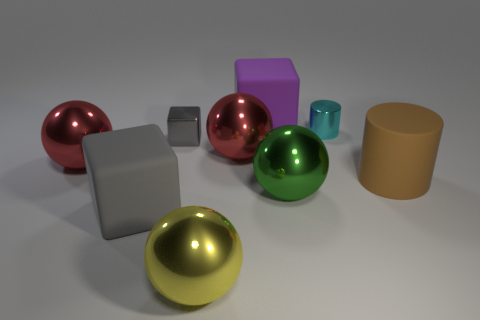Add 1 tiny brown matte things. How many objects exist? 10 Subtract all balls. How many objects are left? 5 Subtract all small metallic cylinders. Subtract all small things. How many objects are left? 6 Add 5 green metallic things. How many green metallic things are left? 6 Add 2 cyan metallic cylinders. How many cyan metallic cylinders exist? 3 Subtract 0 gray cylinders. How many objects are left? 9 